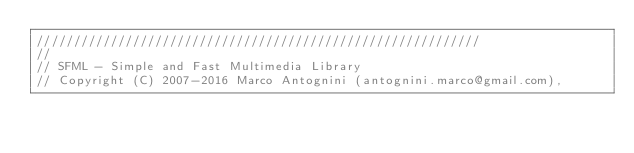<code> <loc_0><loc_0><loc_500><loc_500><_ObjectiveC_>////////////////////////////////////////////////////////////
//
// SFML - Simple and Fast Multimedia Library
// Copyright (C) 2007-2016 Marco Antognini (antognini.marco@gmail.com),</code> 